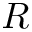<formula> <loc_0><loc_0><loc_500><loc_500>R</formula> 